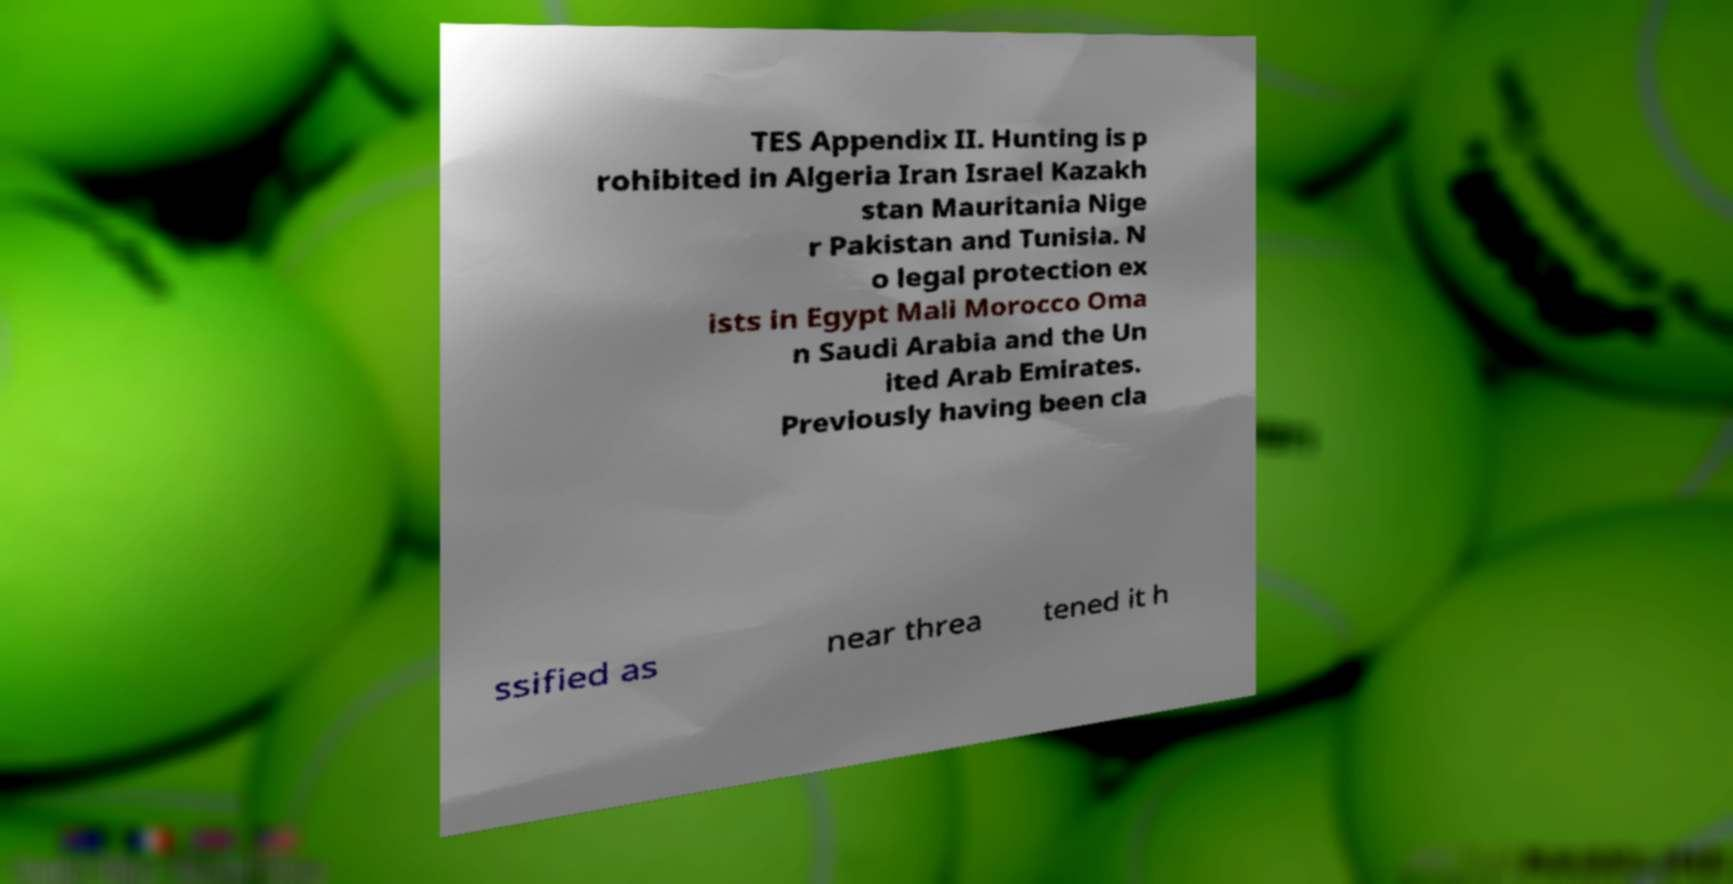For documentation purposes, I need the text within this image transcribed. Could you provide that? TES Appendix II. Hunting is p rohibited in Algeria Iran Israel Kazakh stan Mauritania Nige r Pakistan and Tunisia. N o legal protection ex ists in Egypt Mali Morocco Oma n Saudi Arabia and the Un ited Arab Emirates. Previously having been cla ssified as near threa tened it h 